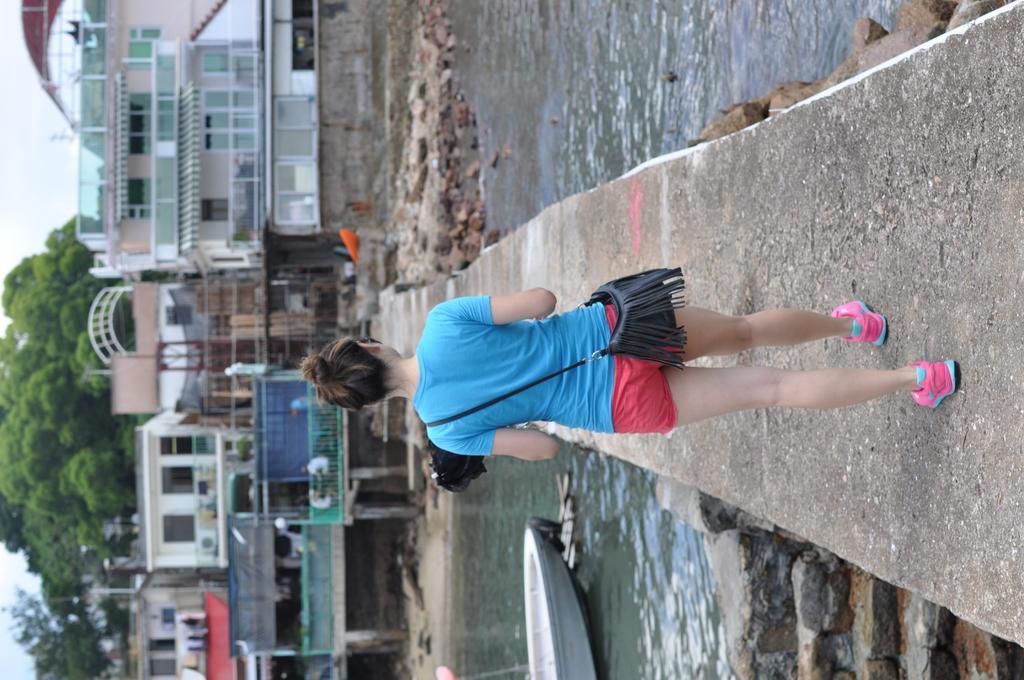Can you describe this image briefly? In this image we can see a woman walking on the pathway. We can also see some stones and a boat in a water body. On the backside we can see a group of buildings, trees and the sky which looks cloudy. 